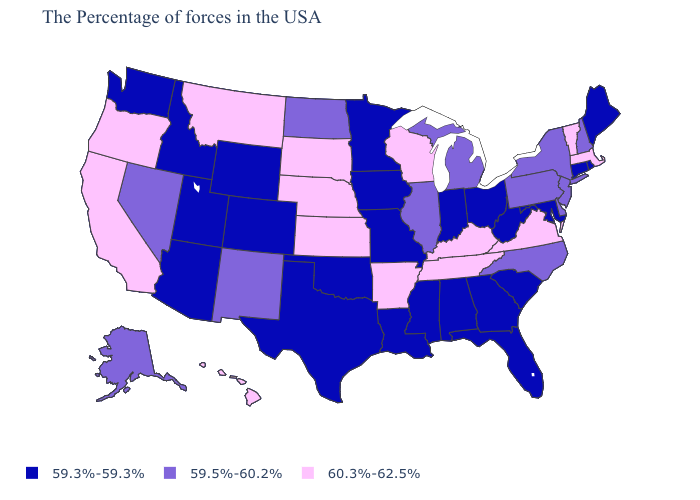What is the value of Alaska?
Be succinct. 59.5%-60.2%. What is the highest value in states that border South Carolina?
Concise answer only. 59.5%-60.2%. Name the states that have a value in the range 59.5%-60.2%?
Answer briefly. New Hampshire, New York, New Jersey, Delaware, Pennsylvania, North Carolina, Michigan, Illinois, North Dakota, New Mexico, Nevada, Alaska. What is the value of Connecticut?
Keep it brief. 59.3%-59.3%. Which states have the highest value in the USA?
Answer briefly. Massachusetts, Vermont, Virginia, Kentucky, Tennessee, Wisconsin, Arkansas, Kansas, Nebraska, South Dakota, Montana, California, Oregon, Hawaii. Among the states that border Vermont , does New York have the highest value?
Quick response, please. No. Which states have the highest value in the USA?
Give a very brief answer. Massachusetts, Vermont, Virginia, Kentucky, Tennessee, Wisconsin, Arkansas, Kansas, Nebraska, South Dakota, Montana, California, Oregon, Hawaii. What is the lowest value in the USA?
Write a very short answer. 59.3%-59.3%. Which states have the lowest value in the Northeast?
Short answer required. Maine, Rhode Island, Connecticut. Does North Dakota have a higher value than Oregon?
Quick response, please. No. Which states hav the highest value in the MidWest?
Give a very brief answer. Wisconsin, Kansas, Nebraska, South Dakota. What is the lowest value in the USA?
Give a very brief answer. 59.3%-59.3%. Does the map have missing data?
Be succinct. No. What is the lowest value in the USA?
Write a very short answer. 59.3%-59.3%. Among the states that border Kansas , does Colorado have the highest value?
Keep it brief. No. 